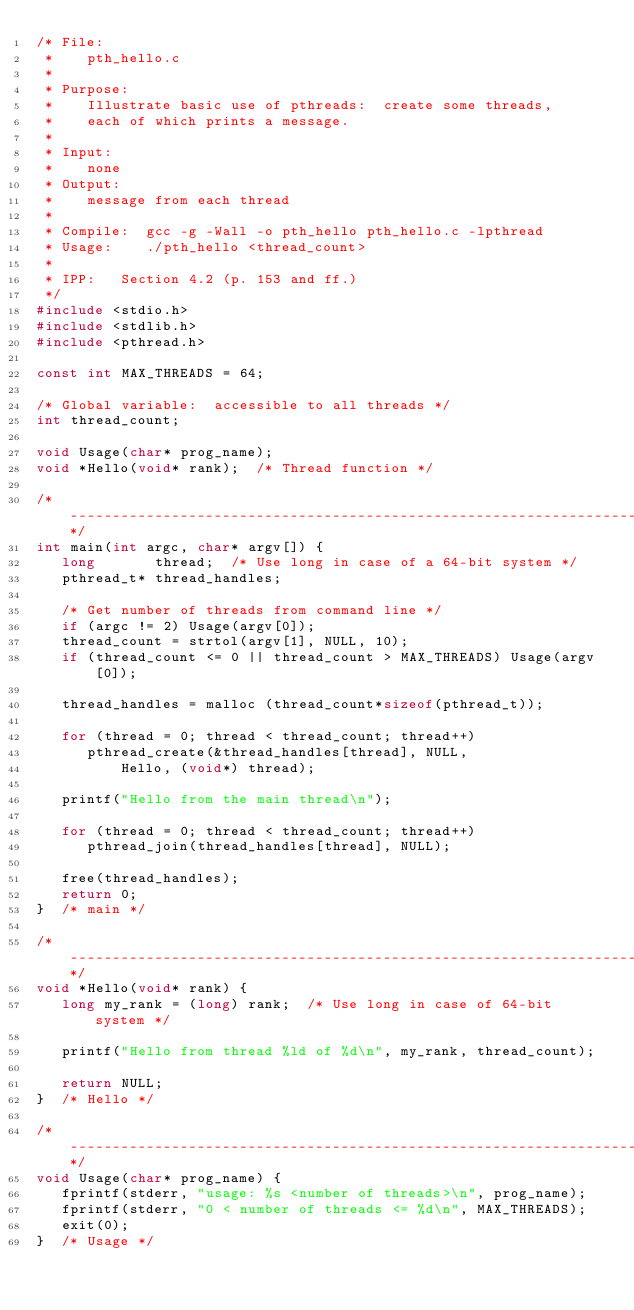Convert code to text. <code><loc_0><loc_0><loc_500><loc_500><_C_>/* File:  
 *    pth_hello.c
 *
 * Purpose:
 *    Illustrate basic use of pthreads:  create some threads,
 *    each of which prints a message.
 *
 * Input:
 *    none
 * Output:
 *    message from each thread
 *
 * Compile:  gcc -g -Wall -o pth_hello pth_hello.c -lpthread
 * Usage:    ./pth_hello <thread_count>
 *
 * IPP:   Section 4.2 (p. 153 and ff.)
 */
#include <stdio.h>
#include <stdlib.h>
#include <pthread.h> 

const int MAX_THREADS = 64;

/* Global variable:  accessible to all threads */
int thread_count;  

void Usage(char* prog_name);
void *Hello(void* rank);  /* Thread function */

/*--------------------------------------------------------------------*/
int main(int argc, char* argv[]) {
   long       thread;  /* Use long in case of a 64-bit system */
   pthread_t* thread_handles; 

   /* Get number of threads from command line */
   if (argc != 2) Usage(argv[0]);
   thread_count = strtol(argv[1], NULL, 10);  
   if (thread_count <= 0 || thread_count > MAX_THREADS) Usage(argv[0]);

   thread_handles = malloc (thread_count*sizeof(pthread_t)); 

   for (thread = 0; thread < thread_count; thread++)  
      pthread_create(&thread_handles[thread], NULL,
          Hello, (void*) thread);  

   printf("Hello from the main thread\n");

   for (thread = 0; thread < thread_count; thread++) 
      pthread_join(thread_handles[thread], NULL); 

   free(thread_handles);
   return 0;
}  /* main */

/*-------------------------------------------------------------------*/
void *Hello(void* rank) {
   long my_rank = (long) rank;  /* Use long in case of 64-bit system */ 

   printf("Hello from thread %ld of %d\n", my_rank, thread_count);

   return NULL;
}  /* Hello */

/*-------------------------------------------------------------------*/
void Usage(char* prog_name) {
   fprintf(stderr, "usage: %s <number of threads>\n", prog_name);
   fprintf(stderr, "0 < number of threads <= %d\n", MAX_THREADS);
   exit(0);
}  /* Usage */
</code> 